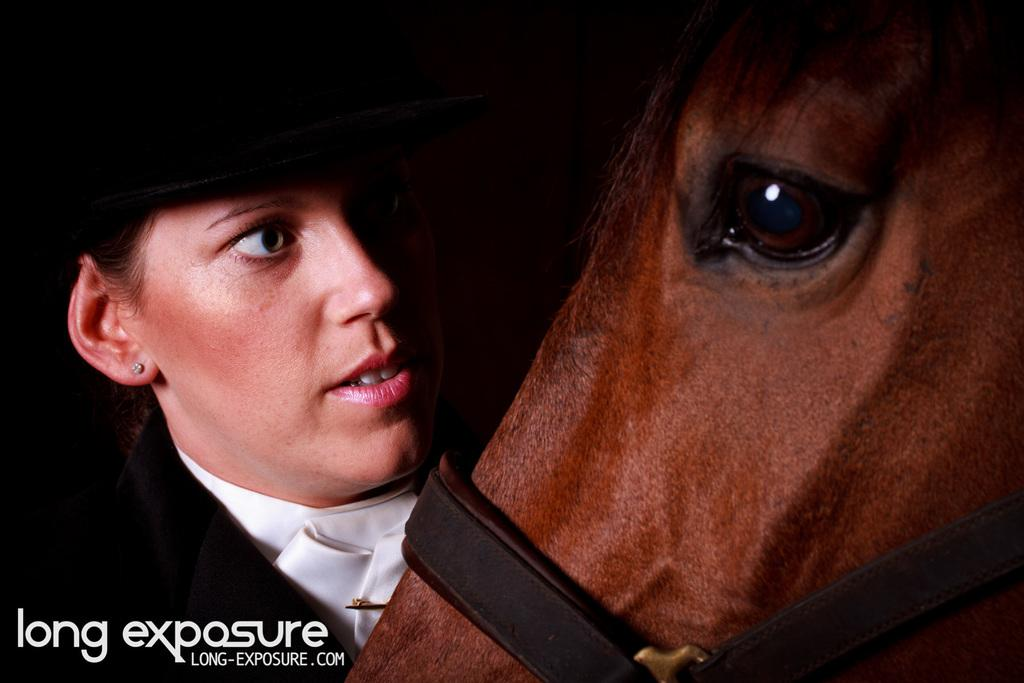Who is the main subject in the image? There is a woman in the image. What is the woman doing in the image? The woman is staring at a horse. What can be seen on the woman's head? The woman is wearing a black hat. What type of jewelry is the woman wearing? The woman is wearing an earring. What is the woman wearing on her upper body? The woman is wearing a black jacket. What is unique about the horse in the image? The horse has a belt. Where is the text located in the image? The text is in the bottom left of the image. What type of stick is the woman holding in her mouth in the image? There is no stick or any object in the woman's mouth in the image. What is the title of the image? The image does not have a title; it is simply a photograph or illustration. 